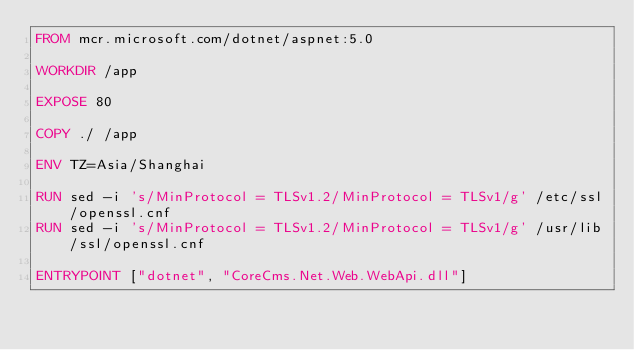<code> <loc_0><loc_0><loc_500><loc_500><_Dockerfile_>FROM mcr.microsoft.com/dotnet/aspnet:5.0

WORKDIR /app

EXPOSE 80

COPY ./ /app

ENV TZ=Asia/Shanghai

RUN sed -i 's/MinProtocol = TLSv1.2/MinProtocol = TLSv1/g' /etc/ssl/openssl.cnf
RUN sed -i 's/MinProtocol = TLSv1.2/MinProtocol = TLSv1/g' /usr/lib/ssl/openssl.cnf

ENTRYPOINT ["dotnet", "CoreCms.Net.Web.WebApi.dll"]</code> 